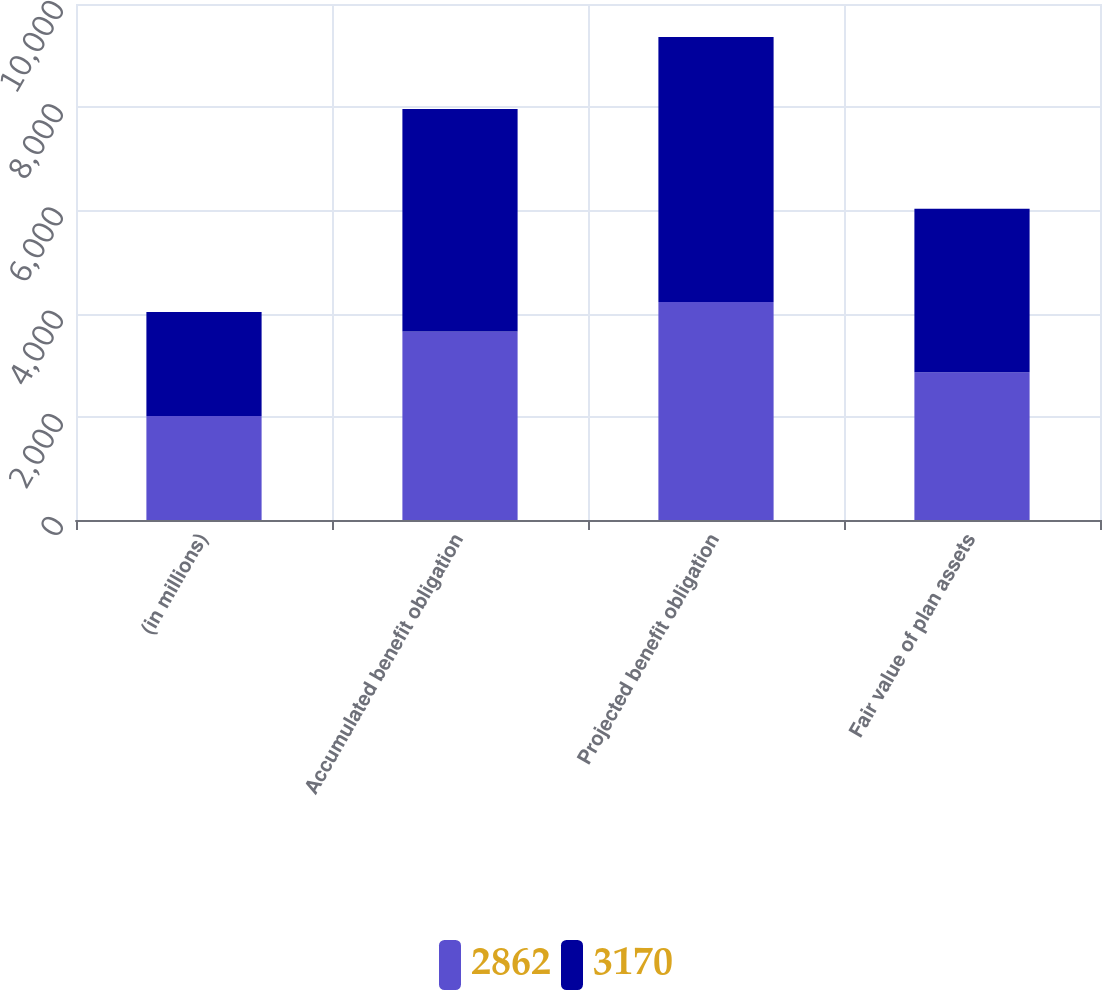<chart> <loc_0><loc_0><loc_500><loc_500><stacked_bar_chart><ecel><fcel>(in millions)<fcel>Accumulated benefit obligation<fcel>Projected benefit obligation<fcel>Fair value of plan assets<nl><fcel>2862<fcel>2015<fcel>3651<fcel>4226<fcel>2862<nl><fcel>3170<fcel>2014<fcel>4315<fcel>5133<fcel>3170<nl></chart> 